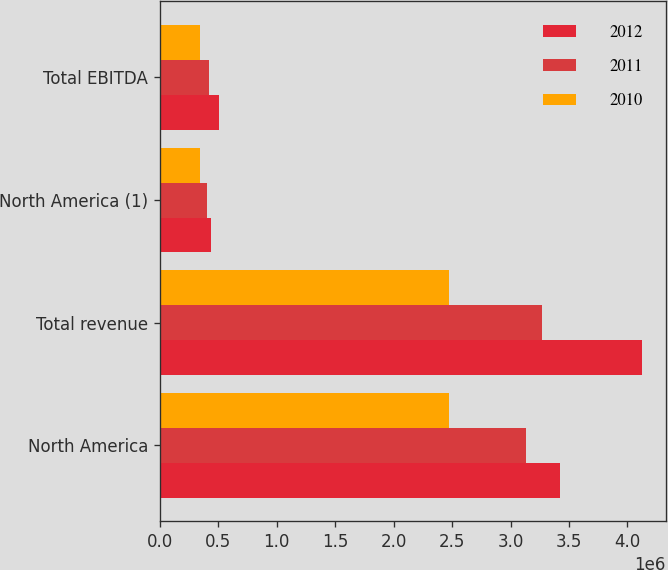Convert chart to OTSL. <chart><loc_0><loc_0><loc_500><loc_500><stacked_bar_chart><ecel><fcel>North America<fcel>Total revenue<fcel>North America (1)<fcel>Total EBITDA<nl><fcel>2012<fcel>3.42686e+06<fcel>4.12293e+06<fcel>440448<fcel>510547<nl><fcel>2011<fcel>3.13138e+06<fcel>3.26986e+06<fcel>405924<fcel>418068<nl><fcel>2010<fcel>2.46988e+06<fcel>2.46988e+06<fcel>339869<fcel>339869<nl></chart> 